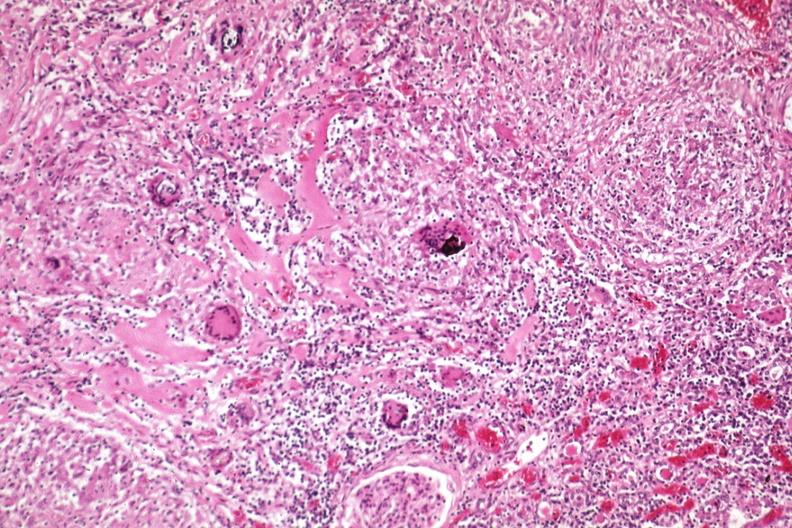what is present?
Answer the question using a single word or phrase. Kidney 